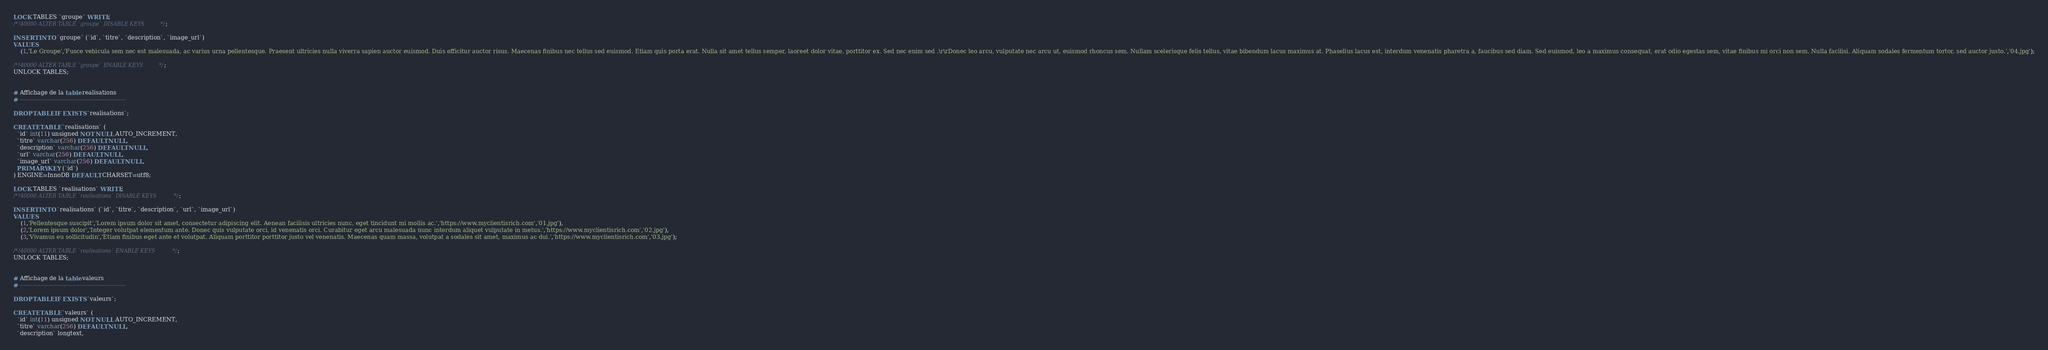Convert code to text. <code><loc_0><loc_0><loc_500><loc_500><_SQL_>LOCK TABLES `groupe` WRITE;
/*!40000 ALTER TABLE `groupe` DISABLE KEYS */;

INSERT INTO `groupe` (`id`, `titre`, `description`, `image_url`)
VALUES
	(1,'Le Groupe','Fusce vehicula sem nec est malesuada, ac varius urna pellentesque. Praesent ultricies nulla viverra sapien auctor euismod. Duis efficitur auctor risus. Maecenas finibus nec tellus sed euismod. Etiam quis porta erat. Nulla sit amet tellus semper, laoreet dolor vitae, porttitor ex. Sed nec enim sed .\r\rDonec leo arcu, vulputate nec arcu ut, euismod rhoncus sem. Nullam scelerisque felis tellus, vitae bibendum lacus maximus at. Phasellus lacus est, interdum venenatis pharetra a, faucibus sed diam. Sed euismod, leo a maximus consequat, erat odio egestas sem, vitae finibus mi orci non sem. Nulla facilisi. Aliquam sodales fermentum tortor, sed auctor justo.','04.jpg');

/*!40000 ALTER TABLE `groupe` ENABLE KEYS */;
UNLOCK TABLES;


# Affichage de la table realisations
# ------------------------------------------------------------

DROP TABLE IF EXISTS `realisations`;

CREATE TABLE `realisations` (
  `id` int(11) unsigned NOT NULL AUTO_INCREMENT,
  `titre` varchar(256) DEFAULT NULL,
  `description` varchar(256) DEFAULT NULL,
  `url` varchar(256) DEFAULT NULL,
  `image_url` varchar(256) DEFAULT NULL,
  PRIMARY KEY (`id`)
) ENGINE=InnoDB DEFAULT CHARSET=utf8;

LOCK TABLES `realisations` WRITE;
/*!40000 ALTER TABLE `realisations` DISABLE KEYS */;

INSERT INTO `realisations` (`id`, `titre`, `description`, `url`, `image_url`)
VALUES
	(1,'Pellentesque suscipit','Lorem ipsum dolor sit amet, consectetur adipiscing elit. Aenean facilisis ultricies nunc, eget tincidunt mi mollis ac.','https://www.myclientisrich.com','01.jpg'),
	(2,'Lorem ipsum dolor','Integer volutpat elementum ante. Donec quis vulputate orci, id venenatis orci. Curabitur eget arcu malesuada nunc interdum aliquet vulputate in metus.','https://www.myclientisrich.com','02.jpg'),
	(3,'Vivamus eu sollicitudin','Etiam finibus eget ante et volutpat. Aliquam porttitor porttitor justo vel venenatis. Maecenas quam massa, volutpat a sodales sit amet, maximus ac dui.','https://www.myclientisrich.com','03.jpg');

/*!40000 ALTER TABLE `realisations` ENABLE KEYS */;
UNLOCK TABLES;


# Affichage de la table valeurs
# ------------------------------------------------------------

DROP TABLE IF EXISTS `valeurs`;

CREATE TABLE `valeurs` (
  `id` int(11) unsigned NOT NULL AUTO_INCREMENT,
  `titre` varchar(256) DEFAULT NULL,
  `description` longtext,</code> 